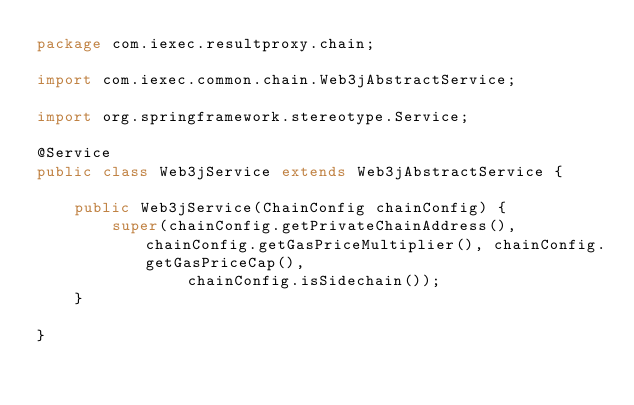<code> <loc_0><loc_0><loc_500><loc_500><_Java_>package com.iexec.resultproxy.chain;

import com.iexec.common.chain.Web3jAbstractService;

import org.springframework.stereotype.Service;

@Service
public class Web3jService extends Web3jAbstractService {

    public Web3jService(ChainConfig chainConfig) {
        super(chainConfig.getPrivateChainAddress(), chainConfig.getGasPriceMultiplier(), chainConfig.getGasPriceCap(),
                chainConfig.isSidechain());
    }

}</code> 